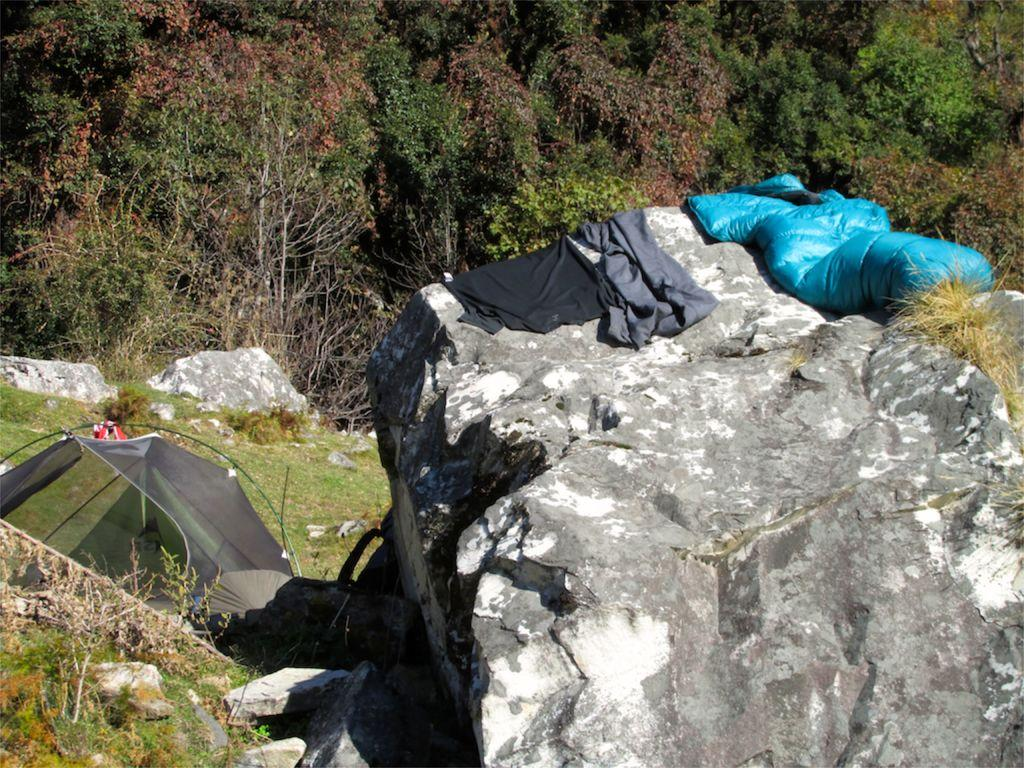What type of vegetation can be seen in the image? There are trees, plants, and rocks visible in the image. What is the surface on which the trees and plants are growing? The ground is visible in the image. What other objects can be seen on the ground? Stones and rocks are present in the image. What type of temporary shelter is visible in the image? Tents are present in the image. What type of fowl can be seen walking around the tents in the image? There are no fowl present in the image; only trees, plants, rocks, stones, and tents can be seen. 